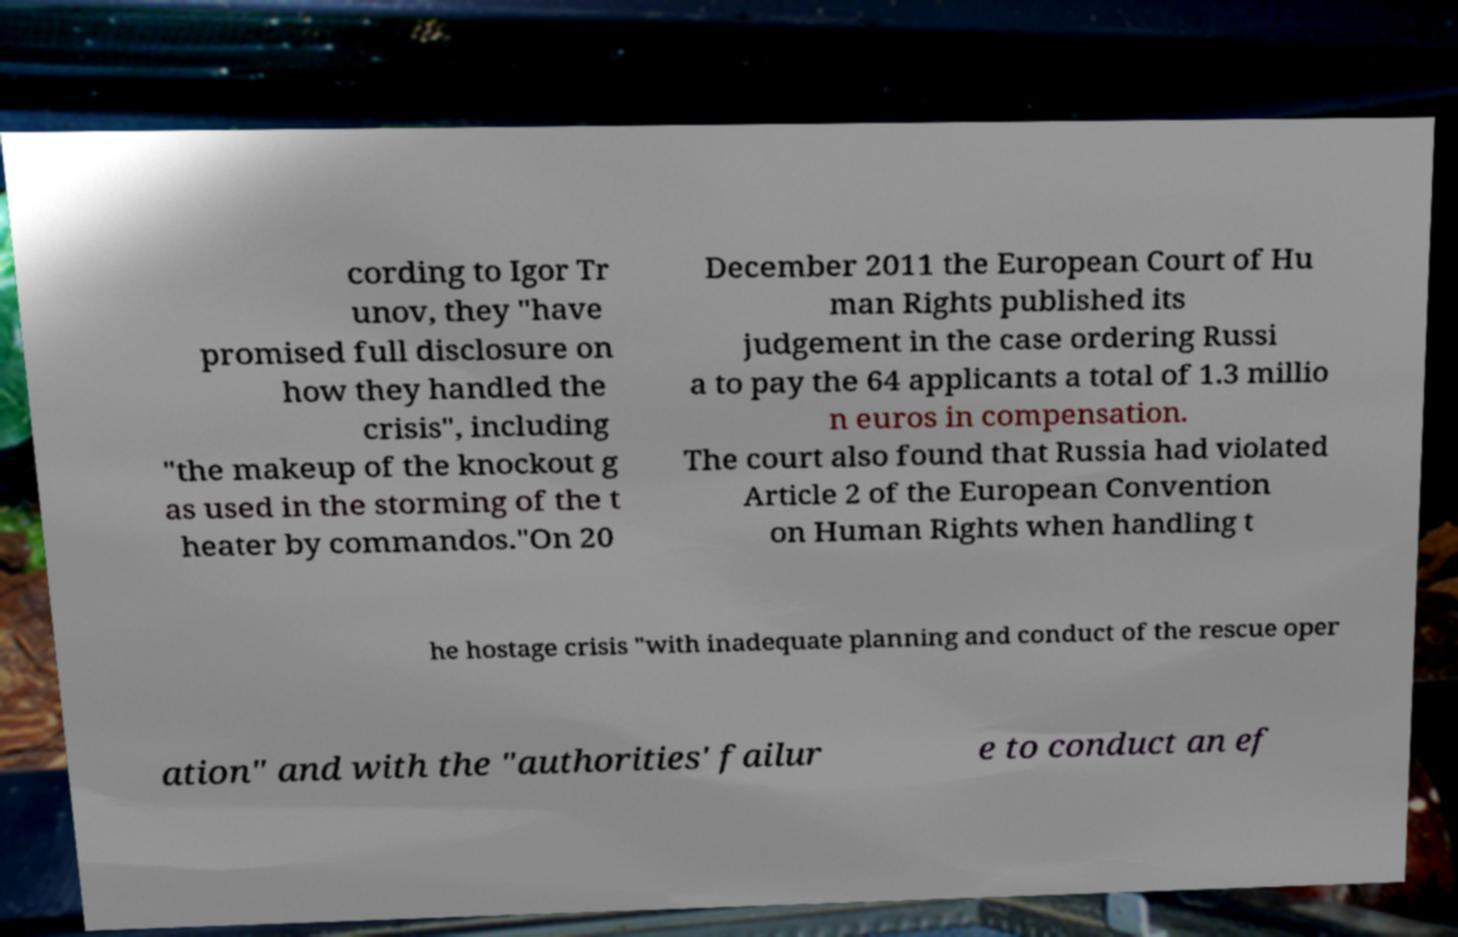Can you accurately transcribe the text from the provided image for me? cording to Igor Tr unov, they "have promised full disclosure on how they handled the crisis", including "the makeup of the knockout g as used in the storming of the t heater by commandos."On 20 December 2011 the European Court of Hu man Rights published its judgement in the case ordering Russi a to pay the 64 applicants a total of 1.3 millio n euros in compensation. The court also found that Russia had violated Article 2 of the European Convention on Human Rights when handling t he hostage crisis "with inadequate planning and conduct of the rescue oper ation" and with the "authorities' failur e to conduct an ef 